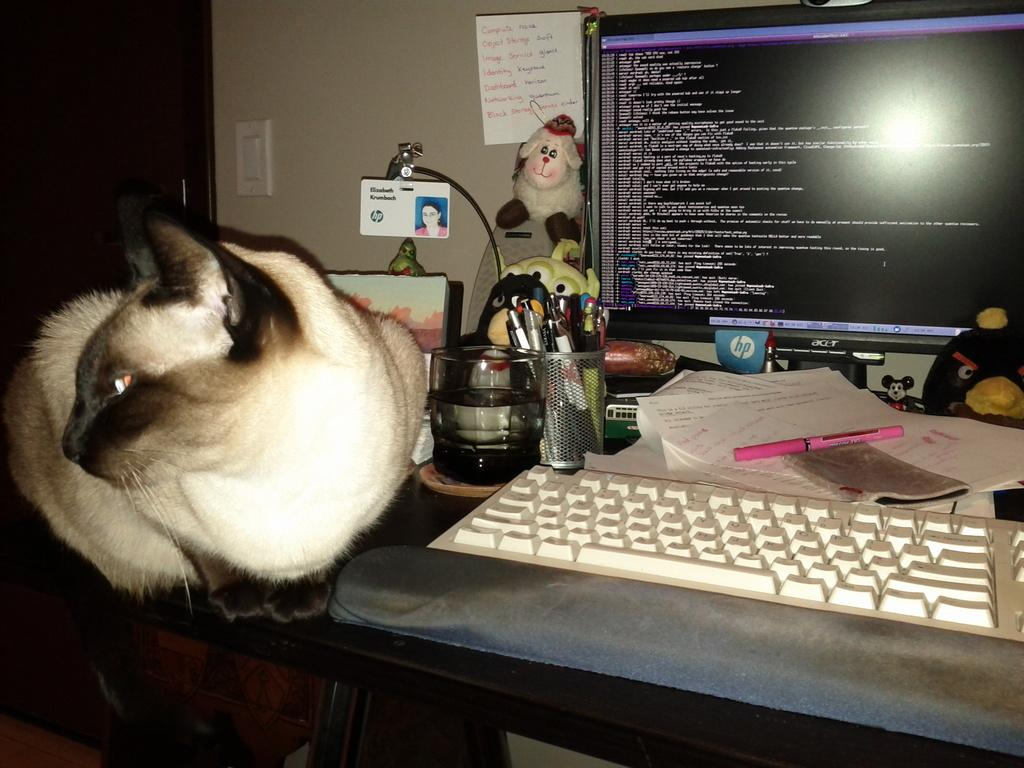What objects are on the table in the image? There is a system with pens and a keyboard on the table. What other item can be seen on the table? There is a toy on top of the table. Can you describe anything on the left side of the image? There is a cat on the left side of the image. How far is the ocean from the cat in the image? There is no ocean present in the image, so it is not possible to determine the distance between the cat and the ocean. 